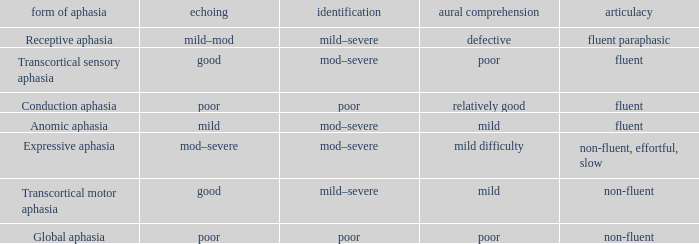Name the comprehension for non-fluent, effortful, slow Mild difficulty. 